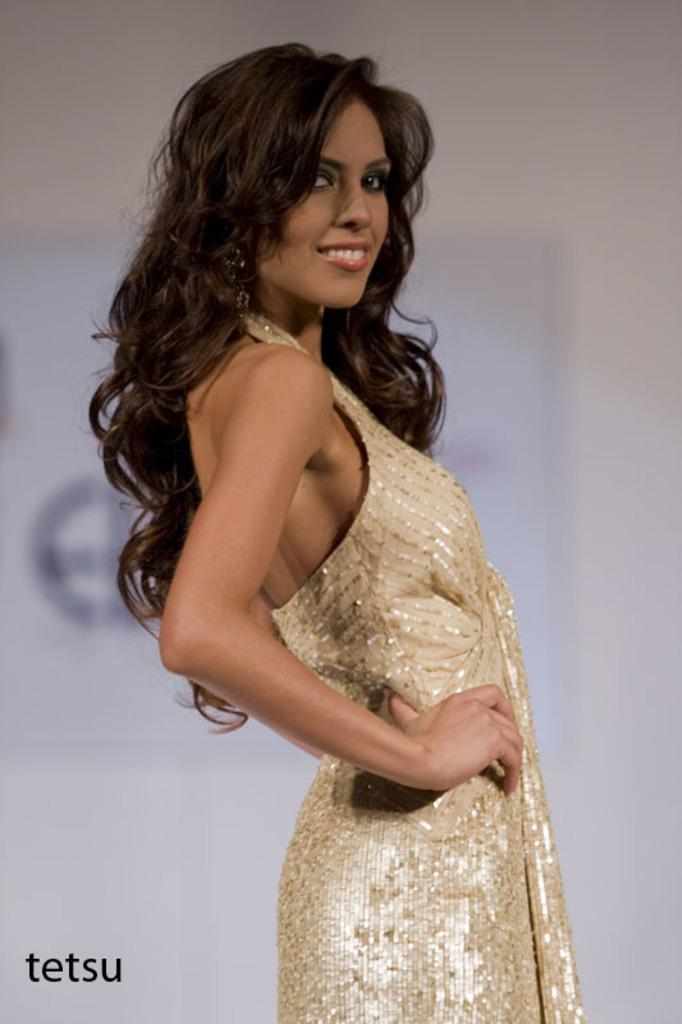What is the main subject of the image? There is a woman standing in the image. Can you describe anything in the background of the image? There is a poster on the wall in the background of the image. What type of silver material is the woman holding in the image? There is no silver material present in the image. How does the woman appear to be feeling in the image? The image does not provide any information about the woman's feelings or emotions. 